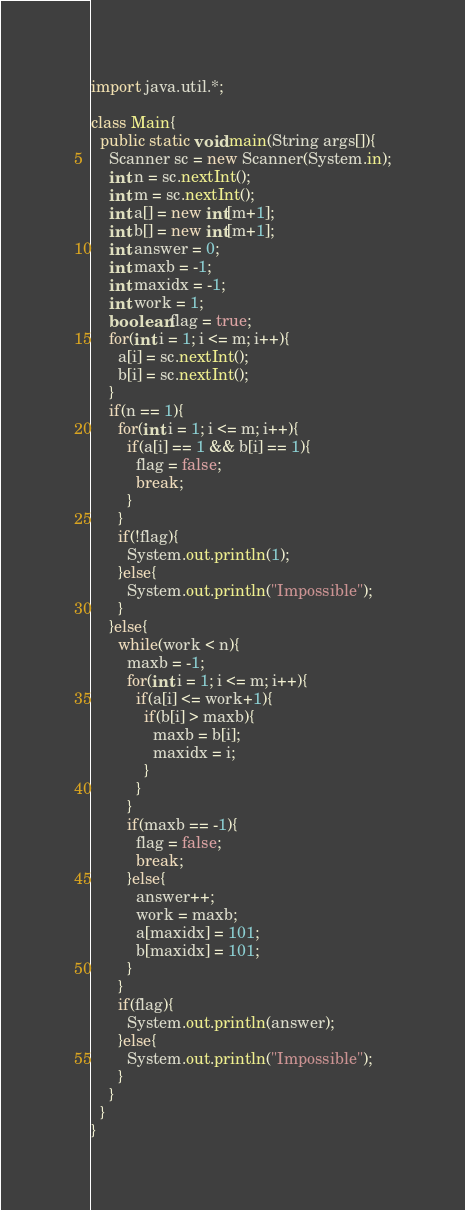<code> <loc_0><loc_0><loc_500><loc_500><_Java_>import java.util.*;

class Main{
  public static void main(String args[]){
    Scanner sc = new Scanner(System.in);
    int n = sc.nextInt();
    int m = sc.nextInt();
    int a[] = new int[m+1];
    int b[] = new int[m+1];
    int answer = 0;
    int maxb = -1;
    int maxidx = -1;
    int work = 1;
    boolean flag = true;
    for(int i = 1; i <= m; i++){
      a[i] = sc.nextInt();
      b[i] = sc.nextInt();
    }
    if(n == 1){
      for(int i = 1; i <= m; i++){
        if(a[i] == 1 && b[i] == 1){
          flag = false;
          break;
        }
      }
      if(!flag){
        System.out.println(1);
      }else{
        System.out.println("Impossible");
      }
    }else{
      while(work < n){
        maxb = -1;
        for(int i = 1; i <= m; i++){
          if(a[i] <= work+1){
            if(b[i] > maxb){
              maxb = b[i];
              maxidx = i;
            }
          }
        }
        if(maxb == -1){
          flag = false;
          break;
        }else{
          answer++;
          work = maxb;
          a[maxidx] = 101;
          b[maxidx] = 101;
        }
      }
      if(flag){
        System.out.println(answer);
      }else{
        System.out.println("Impossible");
      }
    }
  }
}

</code> 